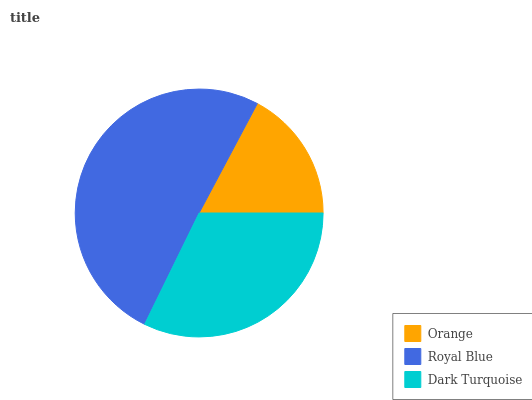Is Orange the minimum?
Answer yes or no. Yes. Is Royal Blue the maximum?
Answer yes or no. Yes. Is Dark Turquoise the minimum?
Answer yes or no. No. Is Dark Turquoise the maximum?
Answer yes or no. No. Is Royal Blue greater than Dark Turquoise?
Answer yes or no. Yes. Is Dark Turquoise less than Royal Blue?
Answer yes or no. Yes. Is Dark Turquoise greater than Royal Blue?
Answer yes or no. No. Is Royal Blue less than Dark Turquoise?
Answer yes or no. No. Is Dark Turquoise the high median?
Answer yes or no. Yes. Is Dark Turquoise the low median?
Answer yes or no. Yes. Is Royal Blue the high median?
Answer yes or no. No. Is Royal Blue the low median?
Answer yes or no. No. 